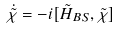Convert formula to latex. <formula><loc_0><loc_0><loc_500><loc_500>\dot { \tilde { \chi } } = - i [ \tilde { H } _ { B S } , \tilde { \chi } ]</formula> 